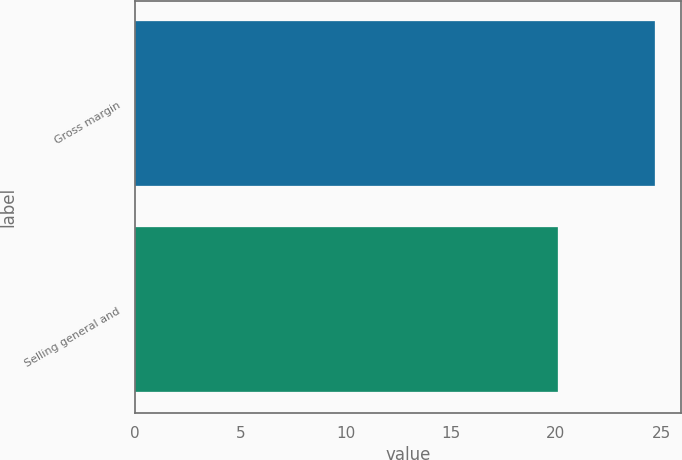Convert chart to OTSL. <chart><loc_0><loc_0><loc_500><loc_500><bar_chart><fcel>Gross margin<fcel>Selling general and<nl><fcel>24.7<fcel>20.1<nl></chart> 